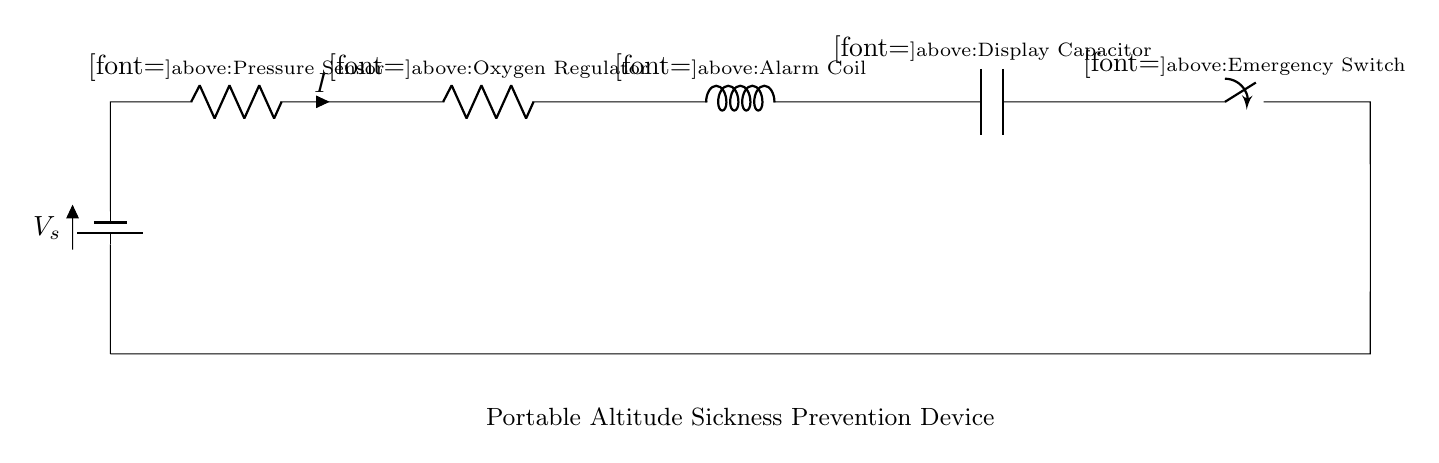What type of circuit is this? This circuit is a series circuit, as all components are connected one after another in a single path for current to flow.
Answer: series What is the function of the pressure sensor? The pressure sensor is used to detect altitude changes, sending signals that can be used for altitude sickness prevention measures.
Answer: altitude detection What is the role of the emergency switch? The emergency switch can be activated to immediately cut off power to the device, providing a quick way to stop operations in case of malfunction or danger.
Answer: cut off power How many resistors are in the circuit? There are two resistors present in the circuit, which are named R1 and R2.
Answer: two What component is connected after the oxygen regulator? Following the oxygen regulator, the alarm coil is connected in the series layout of the circuit.
Answer: alarm coil If the voltage source is 12 volts, what is the same current throughout the circuit? In a series circuit, the same current flows through all components, so it is equal to what is determined by the voltage and total resistance in the circuit.
Answer: equal current What does the display capacitor do in this circuit? The display capacitor is likely used to smooth out fluctuations in power supply, ensuring stable operation of the display and possibly providing temporary storage for electrical energy.
Answer: stabilize power 